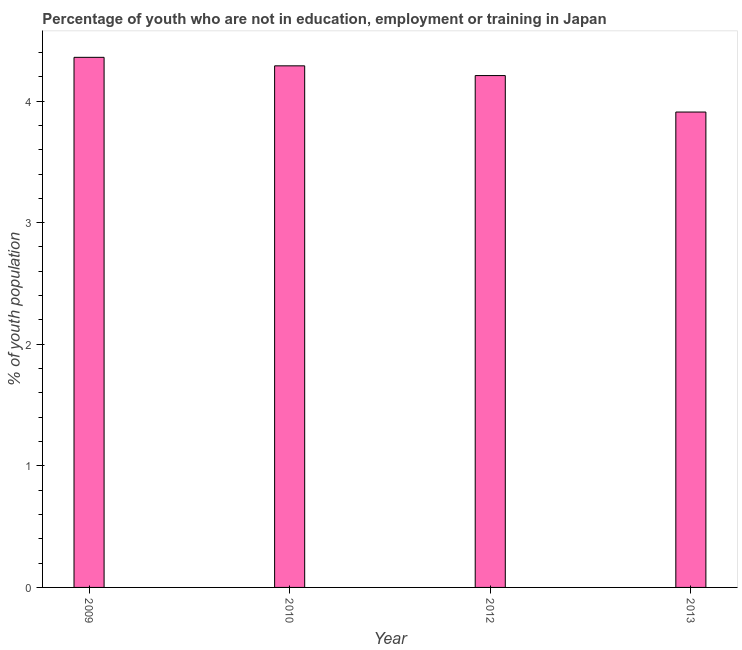Does the graph contain grids?
Offer a very short reply. No. What is the title of the graph?
Offer a very short reply. Percentage of youth who are not in education, employment or training in Japan. What is the label or title of the Y-axis?
Offer a very short reply. % of youth population. What is the unemployed youth population in 2013?
Provide a succinct answer. 3.91. Across all years, what is the maximum unemployed youth population?
Keep it short and to the point. 4.36. Across all years, what is the minimum unemployed youth population?
Provide a succinct answer. 3.91. What is the sum of the unemployed youth population?
Provide a short and direct response. 16.77. What is the difference between the unemployed youth population in 2009 and 2010?
Make the answer very short. 0.07. What is the average unemployed youth population per year?
Give a very brief answer. 4.19. What is the median unemployed youth population?
Your response must be concise. 4.25. Do a majority of the years between 2009 and 2010 (inclusive) have unemployed youth population greater than 1.2 %?
Your response must be concise. Yes. What is the ratio of the unemployed youth population in 2009 to that in 2013?
Your answer should be very brief. 1.11. What is the difference between the highest and the second highest unemployed youth population?
Offer a terse response. 0.07. Is the sum of the unemployed youth population in 2012 and 2013 greater than the maximum unemployed youth population across all years?
Ensure brevity in your answer.  Yes. What is the difference between the highest and the lowest unemployed youth population?
Keep it short and to the point. 0.45. Are the values on the major ticks of Y-axis written in scientific E-notation?
Offer a terse response. No. What is the % of youth population of 2009?
Keep it short and to the point. 4.36. What is the % of youth population in 2010?
Ensure brevity in your answer.  4.29. What is the % of youth population of 2012?
Keep it short and to the point. 4.21. What is the % of youth population of 2013?
Provide a short and direct response. 3.91. What is the difference between the % of youth population in 2009 and 2010?
Your answer should be very brief. 0.07. What is the difference between the % of youth population in 2009 and 2013?
Provide a short and direct response. 0.45. What is the difference between the % of youth population in 2010 and 2013?
Give a very brief answer. 0.38. What is the difference between the % of youth population in 2012 and 2013?
Provide a succinct answer. 0.3. What is the ratio of the % of youth population in 2009 to that in 2012?
Keep it short and to the point. 1.04. What is the ratio of the % of youth population in 2009 to that in 2013?
Make the answer very short. 1.11. What is the ratio of the % of youth population in 2010 to that in 2013?
Provide a succinct answer. 1.1. What is the ratio of the % of youth population in 2012 to that in 2013?
Your answer should be very brief. 1.08. 